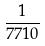<formula> <loc_0><loc_0><loc_500><loc_500>\frac { 1 } { 7 7 1 0 }</formula> 